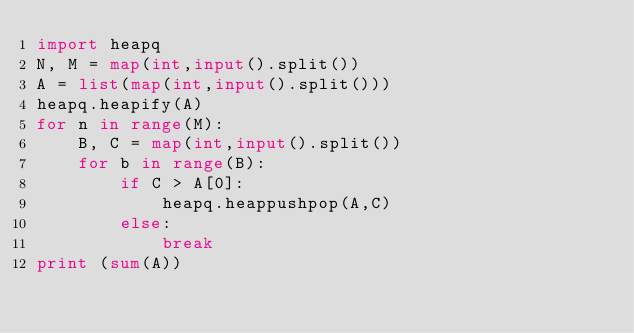<code> <loc_0><loc_0><loc_500><loc_500><_Python_>import heapq
N, M = map(int,input().split())
A = list(map(int,input().split()))
heapq.heapify(A)
for n in range(M):
    B, C = map(int,input().split())
    for b in range(B):
        if C > A[0]:
            heapq.heappushpop(A,C)
        else:
            break
print (sum(A))

</code> 